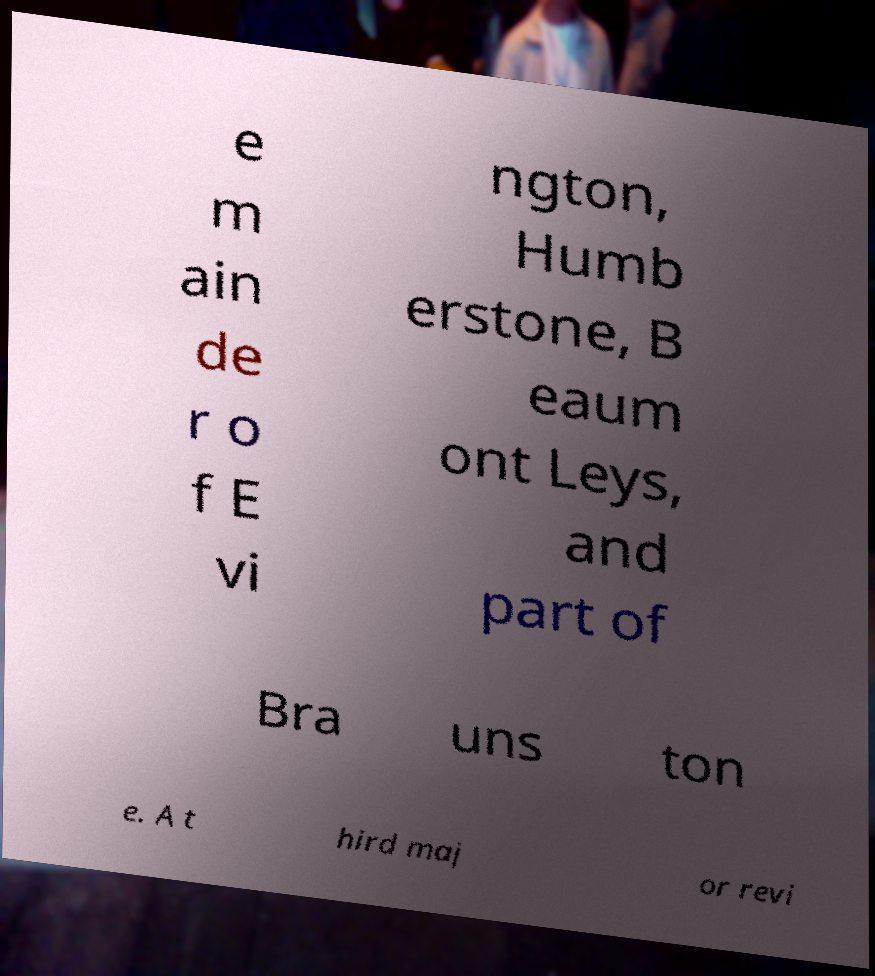Can you accurately transcribe the text from the provided image for me? e m ain de r o f E vi ngton, Humb erstone, B eaum ont Leys, and part of Bra uns ton e. A t hird maj or revi 